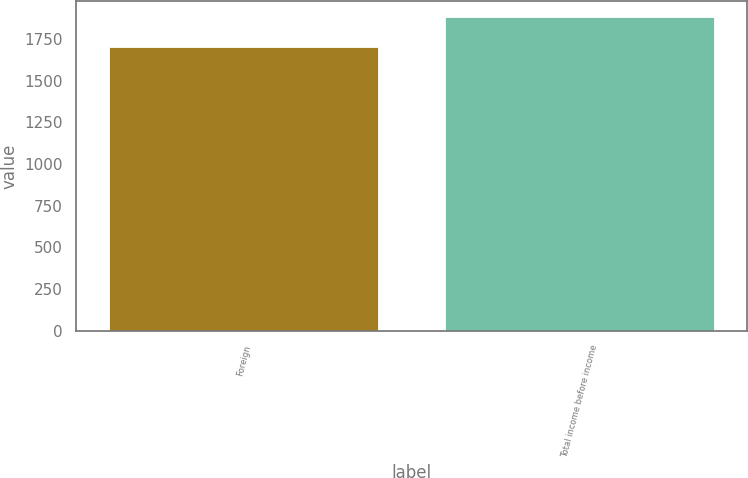Convert chart. <chart><loc_0><loc_0><loc_500><loc_500><bar_chart><fcel>Foreign<fcel>Total income before income<nl><fcel>1700<fcel>1884<nl></chart> 